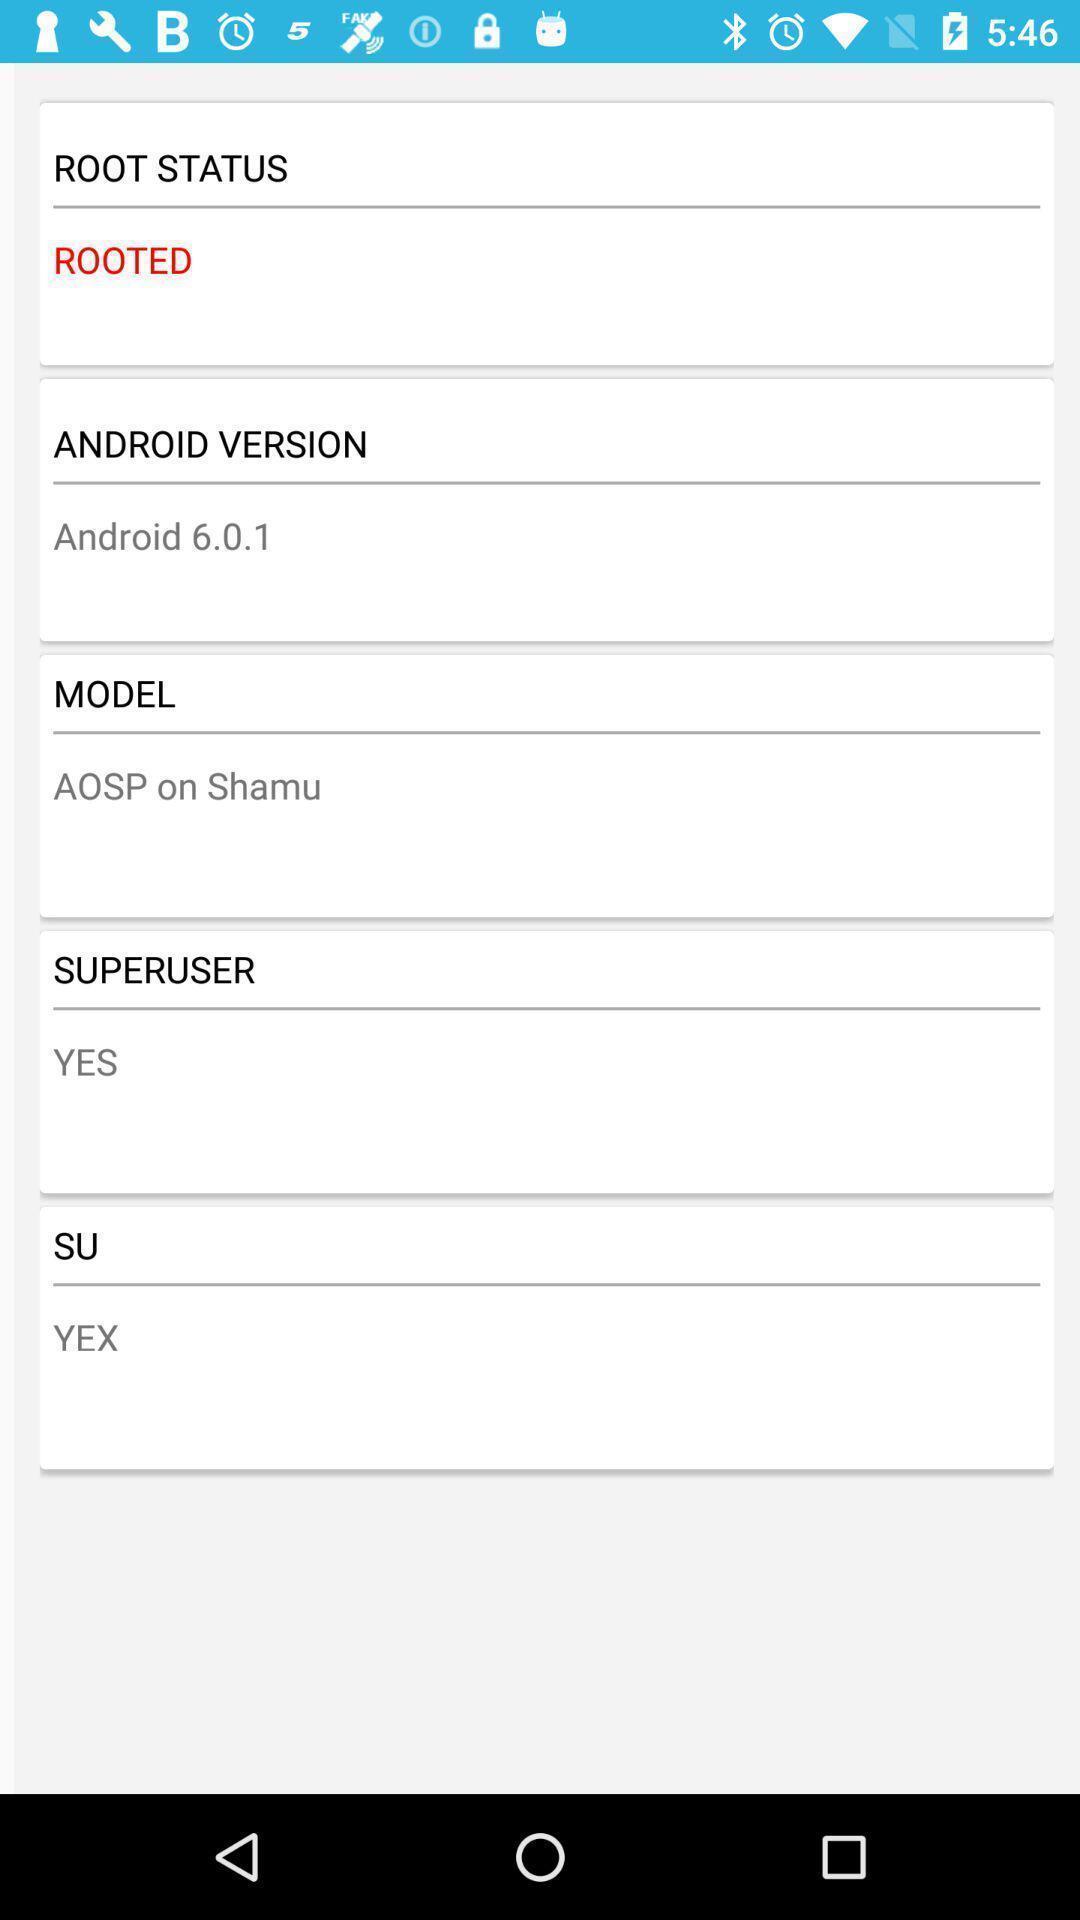Provide a textual representation of this image. Screen displaying different list of information. 